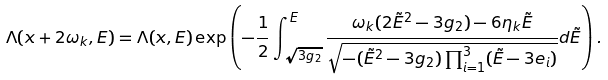Convert formula to latex. <formula><loc_0><loc_0><loc_500><loc_500>& \Lambda ( x + 2 \omega _ { k } , E ) = \Lambda ( x , E ) \exp \left ( - \frac { 1 } { 2 } \int _ { \sqrt { 3 g _ { 2 } } } ^ { E } \frac { \omega _ { k } ( 2 \tilde { E } ^ { 2 } - 3 g _ { 2 } ) - 6 \eta _ { k } \tilde { E } } { \sqrt { - ( \tilde { E } ^ { 2 } - 3 g _ { 2 } ) \prod _ { i = 1 } ^ { 3 } ( \tilde { E } - 3 e _ { i } ) } } d \tilde { E } \right ) .</formula> 